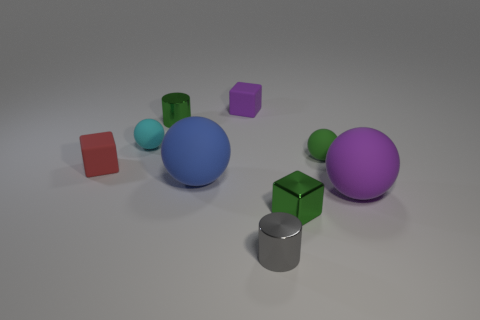Add 1 cyan matte balls. How many objects exist? 10 Subtract all balls. How many objects are left? 5 Subtract all cyan rubber things. Subtract all small green cylinders. How many objects are left? 7 Add 1 blue matte balls. How many blue matte balls are left? 2 Add 7 tiny purple blocks. How many tiny purple blocks exist? 8 Subtract 0 cyan cylinders. How many objects are left? 9 